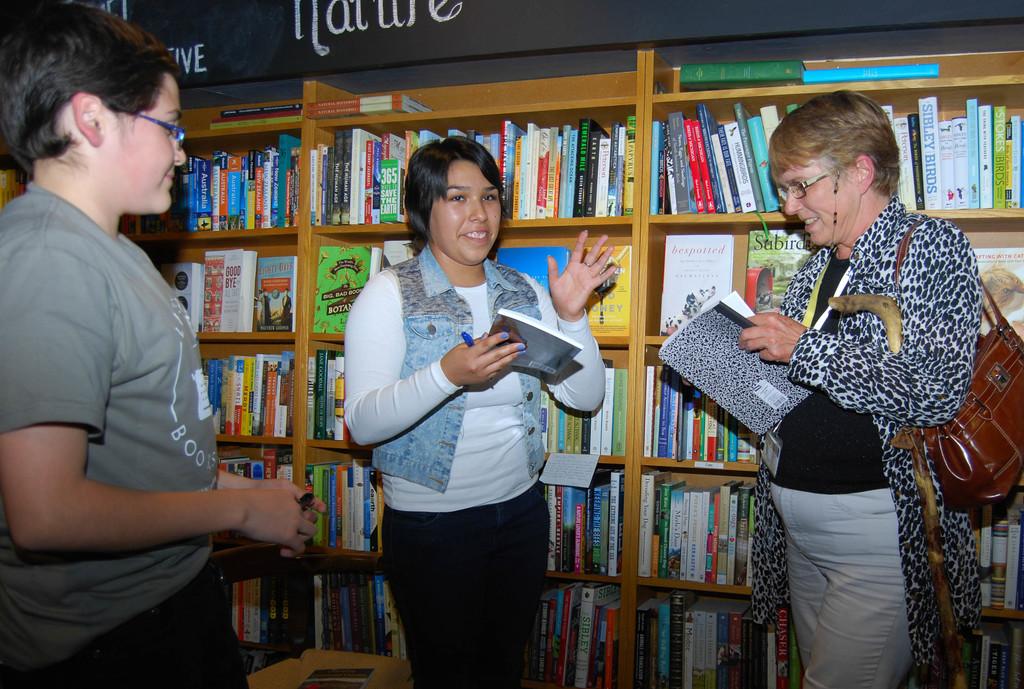What does the word above the middle woman's head say?
Your answer should be very brief. Nature. What letters are visible on the left person's shirt?
Your answer should be very brief. Boo. 